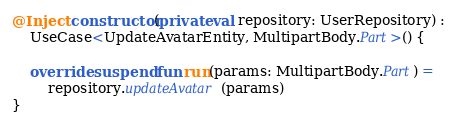Convert code to text. <code><loc_0><loc_0><loc_500><loc_500><_Kotlin_>@Inject constructor(private val repository: UserRepository) :
    UseCase<UpdateAvatarEntity, MultipartBody.Part>() {

    override suspend fun run(params: MultipartBody.Part) =
        repository.updateAvatar(params)
}</code> 